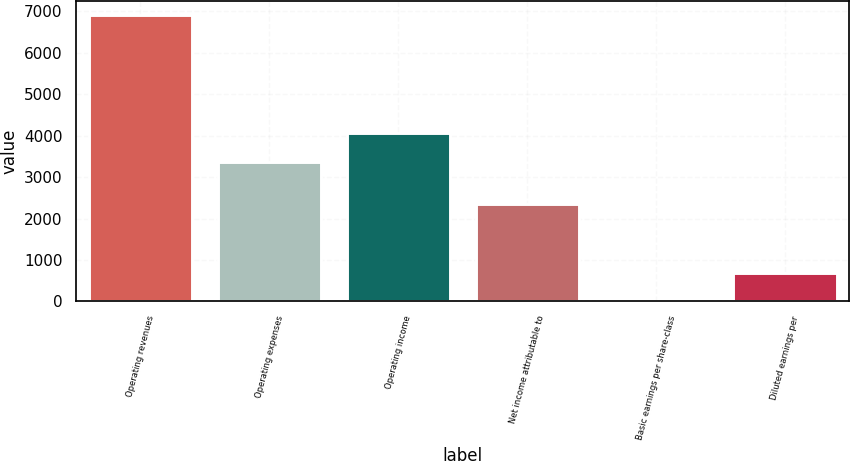Convert chart. <chart><loc_0><loc_0><loc_500><loc_500><bar_chart><fcel>Operating revenues<fcel>Operating expenses<fcel>Operating income<fcel>Net income attributable to<fcel>Basic earnings per share-class<fcel>Diluted earnings per<nl><fcel>6911<fcel>3373<fcel>4063.79<fcel>2353<fcel>3.1<fcel>693.89<nl></chart> 